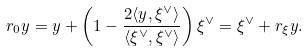<formula> <loc_0><loc_0><loc_500><loc_500>r _ { 0 } y = y + \left ( 1 - \frac { 2 \langle y , \xi ^ { \vee } \rangle } { \langle \xi ^ { \vee } , \xi ^ { \vee } \rangle } \right ) \xi ^ { \vee } = \xi ^ { \vee } + r _ { \xi } y .</formula> 